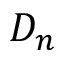Convert formula to latex. <formula><loc_0><loc_0><loc_500><loc_500>D _ { n }</formula> 